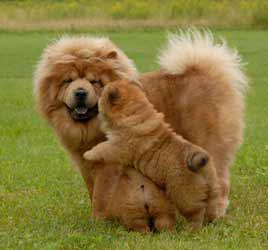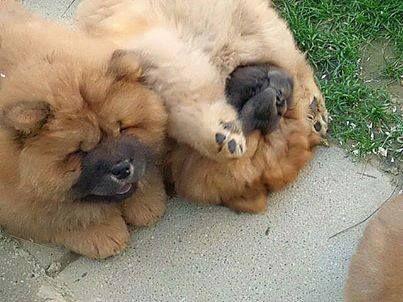The first image is the image on the left, the second image is the image on the right. Analyze the images presented: Is the assertion "One of the images shows only one dog." valid? Answer yes or no. No. The first image is the image on the left, the second image is the image on the right. Examine the images to the left and right. Is the description "One dog in the image on the left is jumping up onto another dog." accurate? Answer yes or no. Yes. 